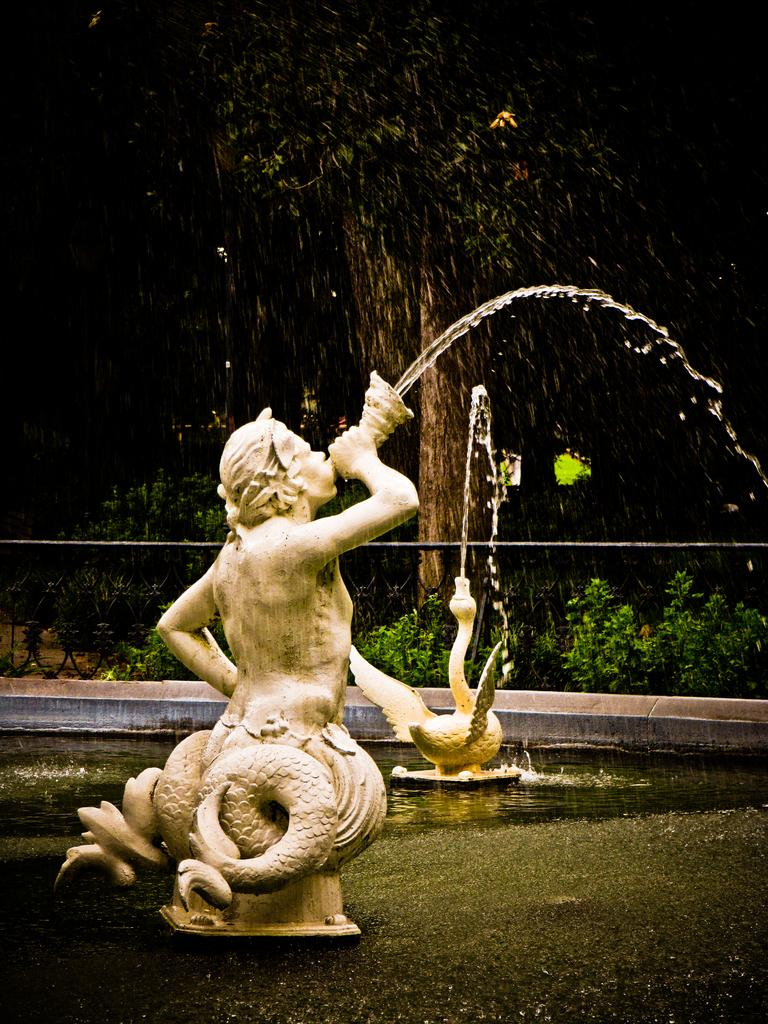What is the main subject in the image? There is a statue in the image. Can you describe the statue's appearance? The statue is white. What can be seen in the background of the image? There are trees and a fountain in the background of the image. What is the color of the trees? The trees are green. What type of discovery was made near the statue in the image? There is no mention of a discovery in the image, as it only features a statue, trees, and a fountain. 